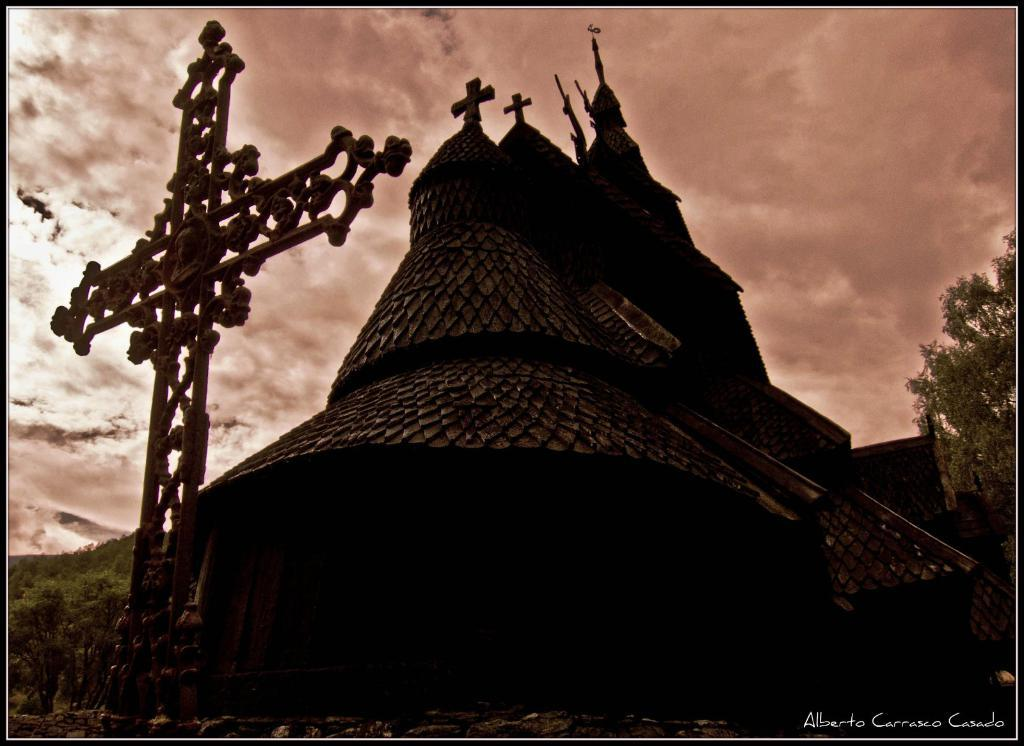What type of structure can be seen in the image? There is a building in the image. What artistic element is present in the image? There is a sculpture in the image. What is the surface on which the building and sculpture are situated? The ground is visible in the image. What type of vegetation is present in the image? There are trees in the image. What part of the natural environment is visible in the image? The sky is visible in the image. What atmospheric feature can be seen in the sky? Clouds are present in the sky. Can you tell me how many boats are docked near the building in the image? There are no boats present in the image; it only features a building, a sculpture, trees, and the sky. What type of hook is attached to the sculpture in the image? There is no hook present on the sculpture in the image. 